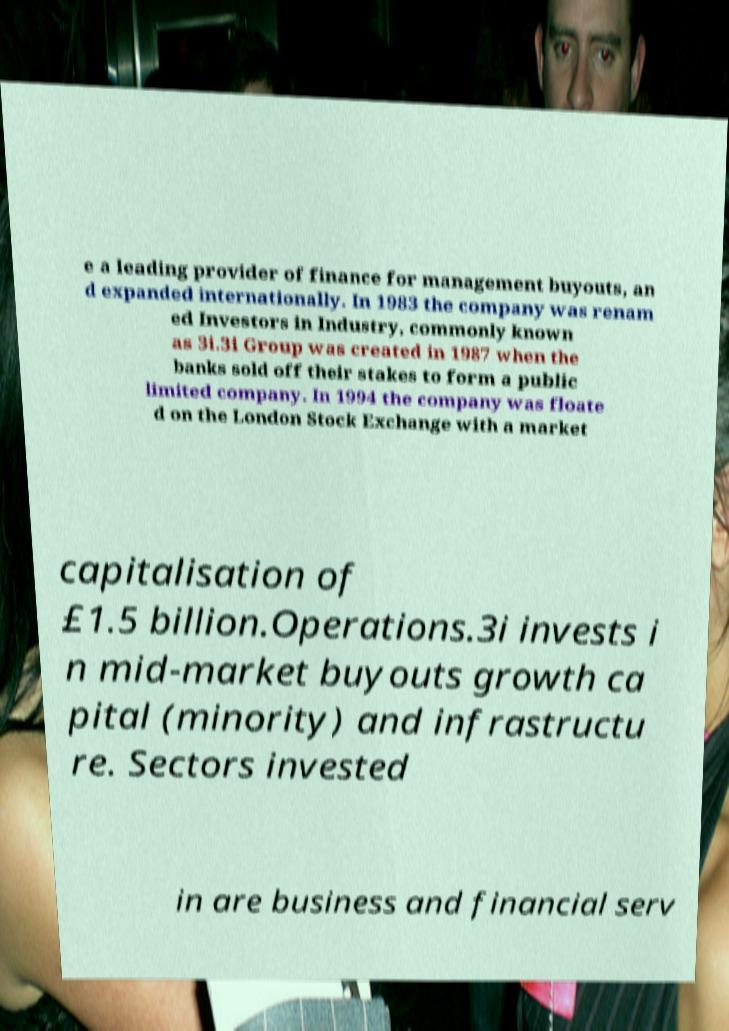For documentation purposes, I need the text within this image transcribed. Could you provide that? e a leading provider of finance for management buyouts, an d expanded internationally. In 1983 the company was renam ed Investors in Industry, commonly known as 3i.3i Group was created in 1987 when the banks sold off their stakes to form a public limited company. In 1994 the company was floate d on the London Stock Exchange with a market capitalisation of £1.5 billion.Operations.3i invests i n mid-market buyouts growth ca pital (minority) and infrastructu re. Sectors invested in are business and financial serv 